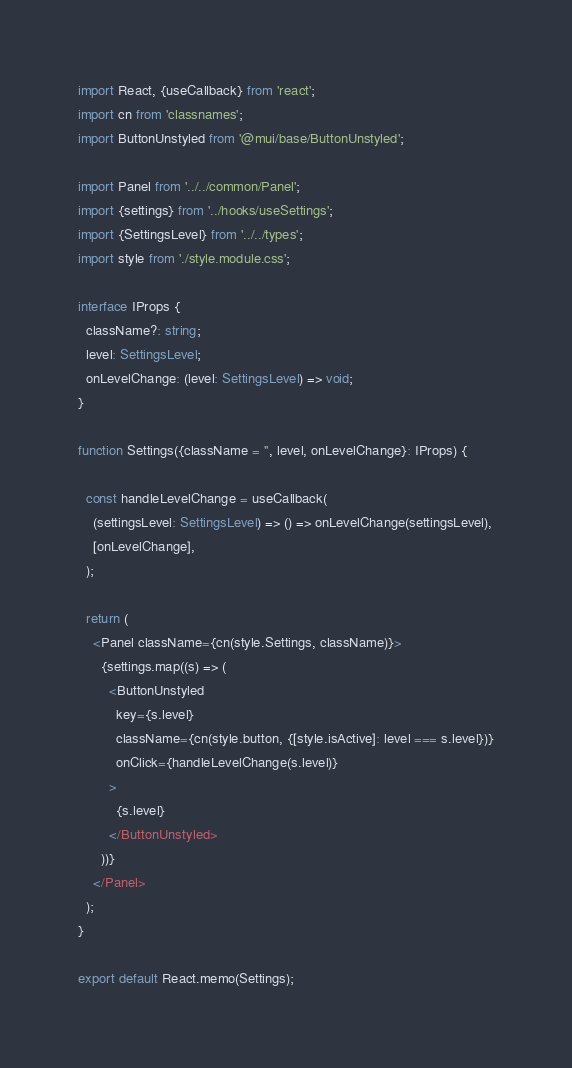<code> <loc_0><loc_0><loc_500><loc_500><_TypeScript_>import React, {useCallback} from 'react';
import cn from 'classnames';
import ButtonUnstyled from '@mui/base/ButtonUnstyled';

import Panel from '../../common/Panel';
import {settings} from '../hooks/useSettings';
import {SettingsLevel} from '../../types';
import style from './style.module.css';

interface IProps {
  className?: string;
  level: SettingsLevel;
  onLevelChange: (level: SettingsLevel) => void;
}

function Settings({className = '', level, onLevelChange}: IProps) {

  const handleLevelChange = useCallback(
    (settingsLevel: SettingsLevel) => () => onLevelChange(settingsLevel),
    [onLevelChange],
  );

  return (
    <Panel className={cn(style.Settings, className)}>
      {settings.map((s) => (
        <ButtonUnstyled
          key={s.level}
          className={cn(style.button, {[style.isActive]: level === s.level})}
          onClick={handleLevelChange(s.level)}
        >
          {s.level}
        </ButtonUnstyled>
      ))}
    </Panel>
  );
}

export default React.memo(Settings);
</code> 